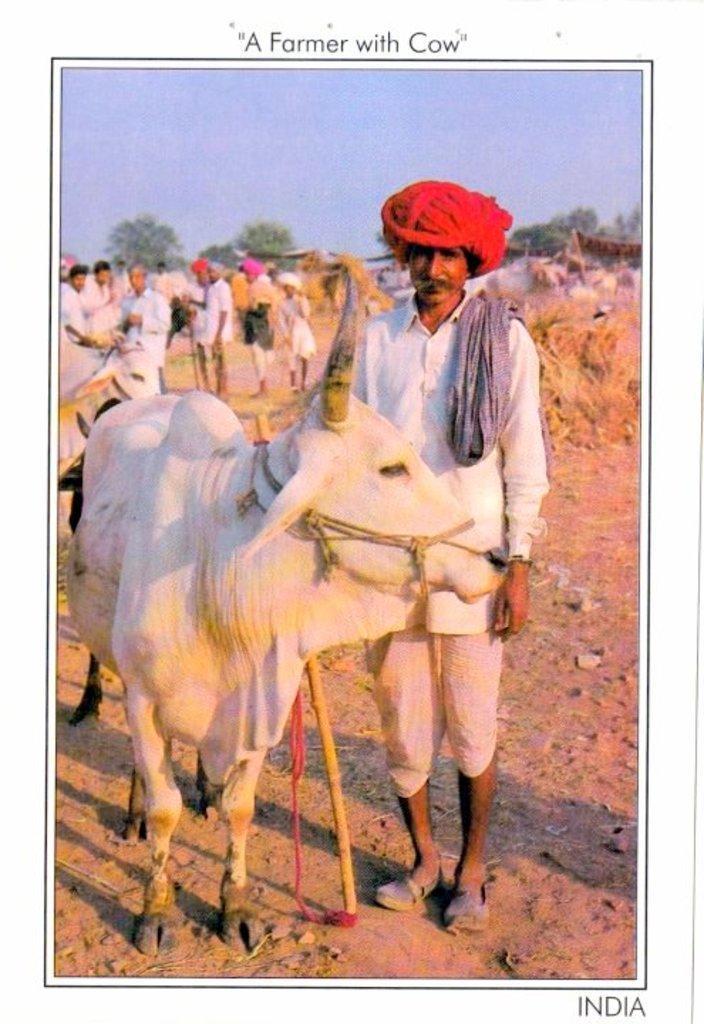Can you describe this image briefly? This is an edited image in this image in the center three is one person who is standing and he is holding one stick, beside him there is one ox and in the background there are some persons who are standing and there are some trees and houses. At the bottom there is sand. 